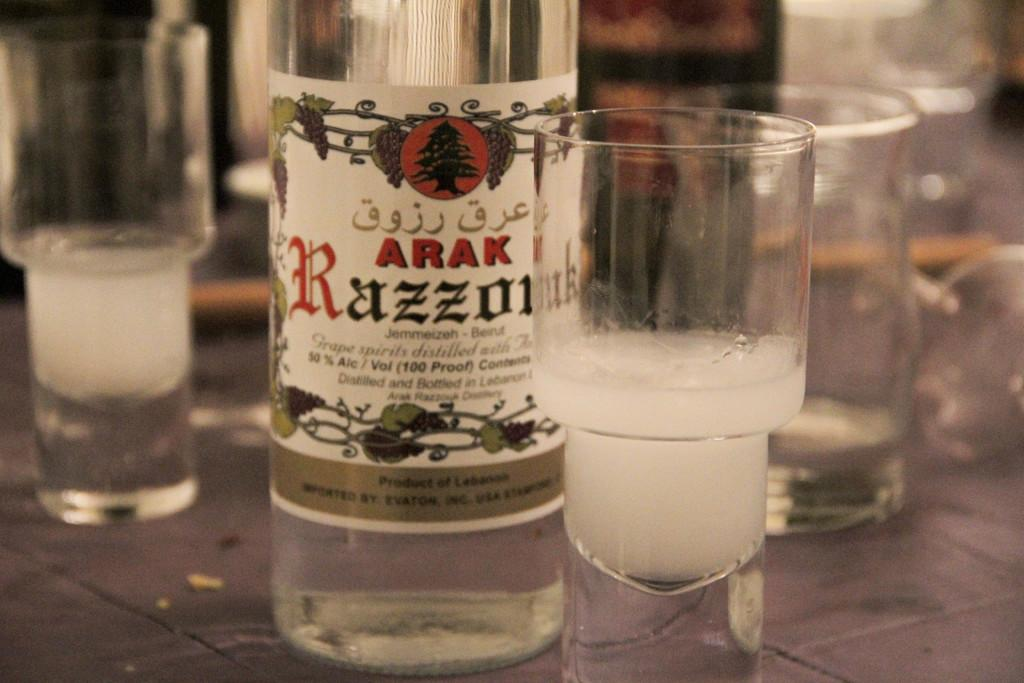<image>
Render a clear and concise summary of the photo. A bottle has the name Arak on it and is one hundred proof alcohol. 